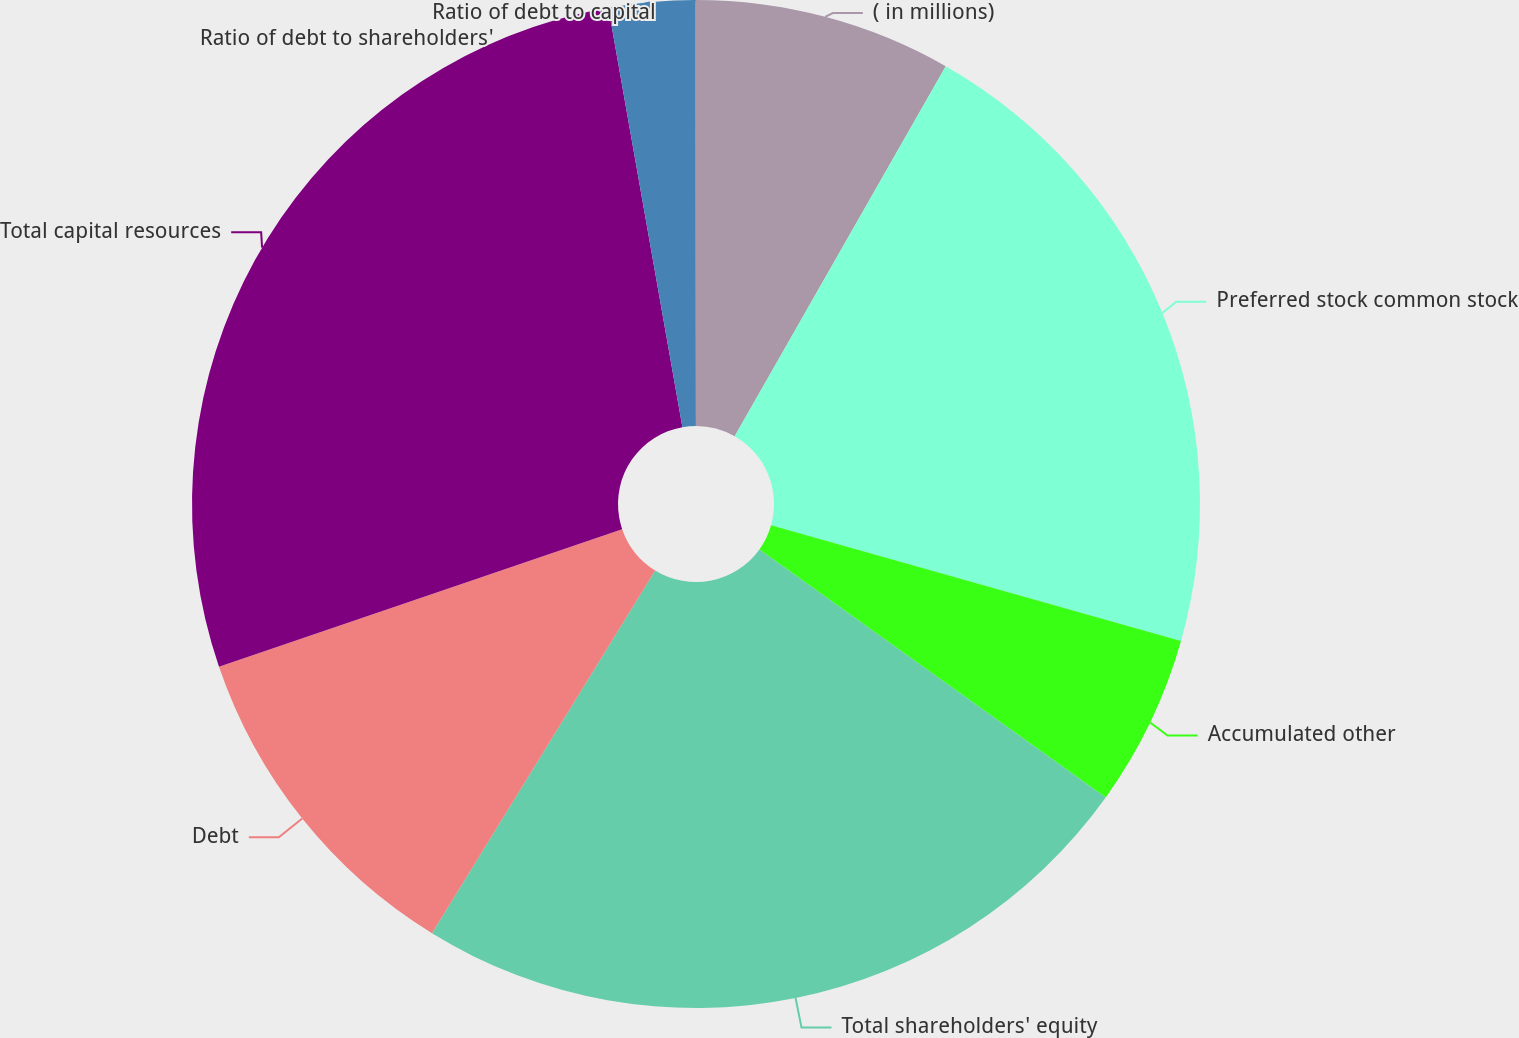Convert chart. <chart><loc_0><loc_0><loc_500><loc_500><pie_chart><fcel>( in millions)<fcel>Preferred stock common stock<fcel>Accumulated other<fcel>Total shareholders' equity<fcel>Debt<fcel>Total capital resources<fcel>Ratio of debt to shareholders'<fcel>Ratio of debt to capital<nl><fcel>8.25%<fcel>21.13%<fcel>5.51%<fcel>23.88%<fcel>10.99%<fcel>27.45%<fcel>2.76%<fcel>0.02%<nl></chart> 